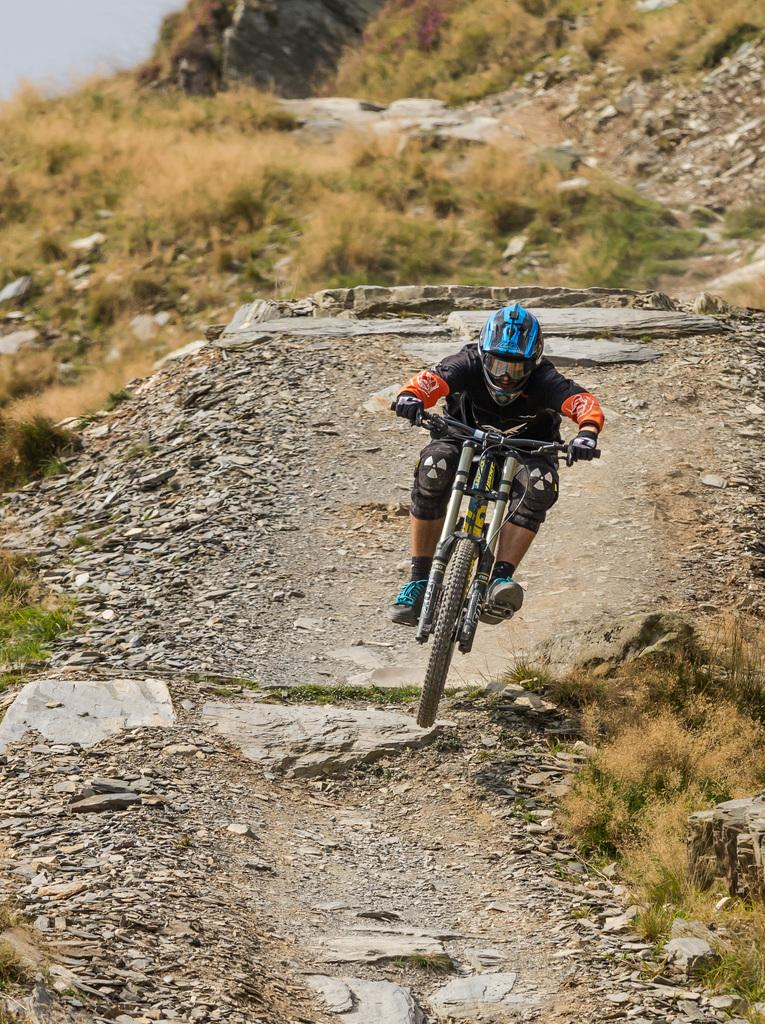What is the person in the image doing? The person is riding a bicycle in the image. What safety precaution is the person taking while riding the bicycle? The person is wearing a helmet. What type of terrain can be seen in the image? There are rocks and grass in the image. Can you see a boat sailing in the air in the image? No, there is no boat sailing in the air in the image. Is there a cannon visible in the image? No, there is no cannon present in the image. 